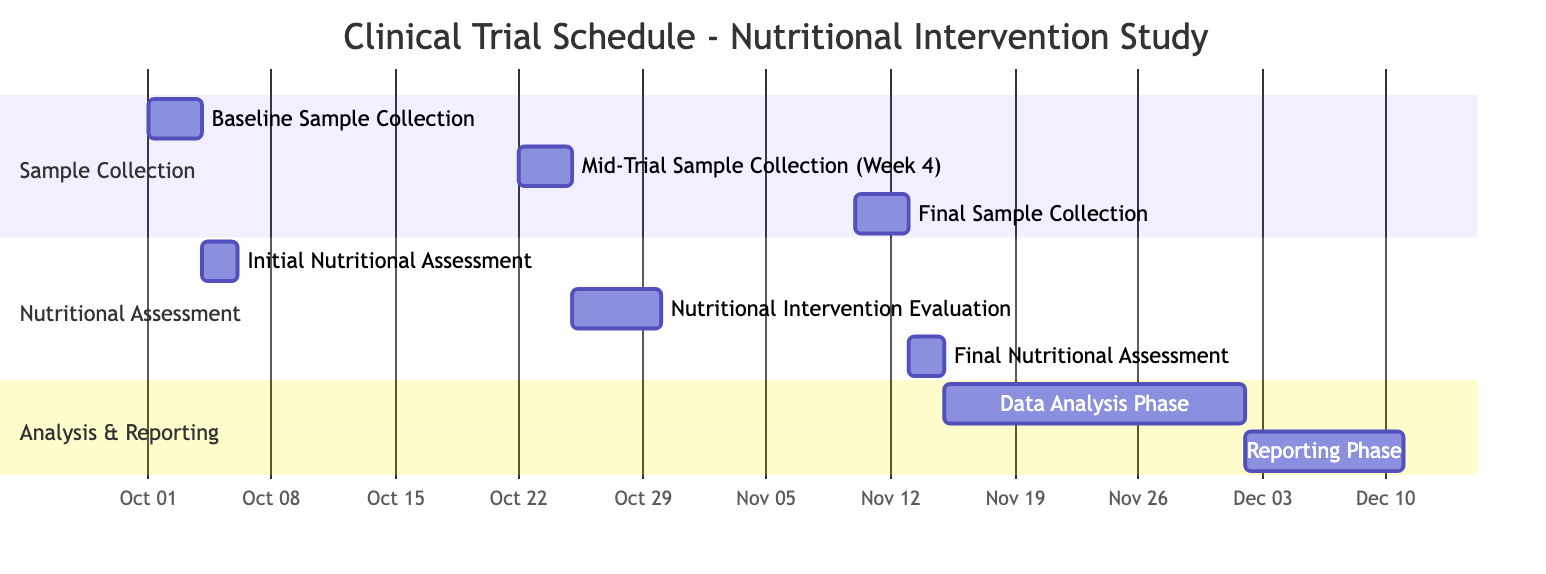What is the duration of the Baseline Sample Collection task? The Baseline Sample Collection task duration is specifically marked as 3 days on the Gantt chart.
Answer: 3 days When does the Final Nutritional Assessment start? According to the Gantt chart, the Final Nutritional Assessment task begins on November 13, 2023.
Answer: November 13, 2023 How many days are allocated for the Data Analysis Phase? The Data Analysis Phase task duration is indicated as 17 days on the Gantt chart, clearly visible in the section labeled "Analysis & Reporting."
Answer: 17 days Which task follows the Mid-Trial Sample Collection? After the Mid-Trial Sample Collection, the next task according to the schedule is the Nutritional Intervention Evaluation, starting on October 25, 2023.
Answer: Nutritional Intervention Evaluation What is the total number of tasks listed in the Gantt chart? By counting each of the tasks presented in the Gantt chart, a total of 8 distinct tasks can be identified.
Answer: 8 tasks What is the end date of the Reporting Phase? The Reporting Phase task ends on December 10, 2023, as designated in the Gantt chart.
Answer: December 10, 2023 Which section contains the Final Sample Collection task? The Final Sample Collection task is included in the "Sample Collection" section, listed alongside the other collection tasks.
Answer: Sample Collection How many days are between the Initial Nutritional Assessment and the Mid-Trial Sample Collection? The Initial Nutritional Assessment ends on October 5, 2023, and the Mid-Trial Sample Collection starts on October 22, 2023, resulting in a gap of 17 days between the two events.
Answer: 17 days 